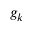Convert formula to latex. <formula><loc_0><loc_0><loc_500><loc_500>g _ { k }</formula> 